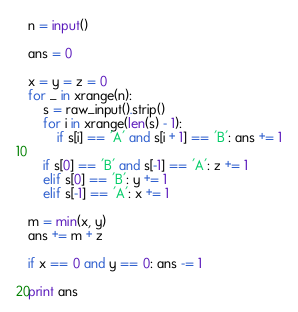<code> <loc_0><loc_0><loc_500><loc_500><_Python_>n = input()

ans = 0

x = y = z = 0
for _ in xrange(n):
    s = raw_input().strip()
    for i in xrange(len(s) - 1):
        if s[i] == 'A' and s[i + 1] == 'B': ans += 1

    if s[0] == 'B' and s[-1] == 'A': z += 1
    elif s[0] == 'B': y += 1
    elif s[-1] == 'A': x += 1

m = min(x, y)
ans += m + z

if x == 0 and y == 0: ans -= 1

print ans</code> 